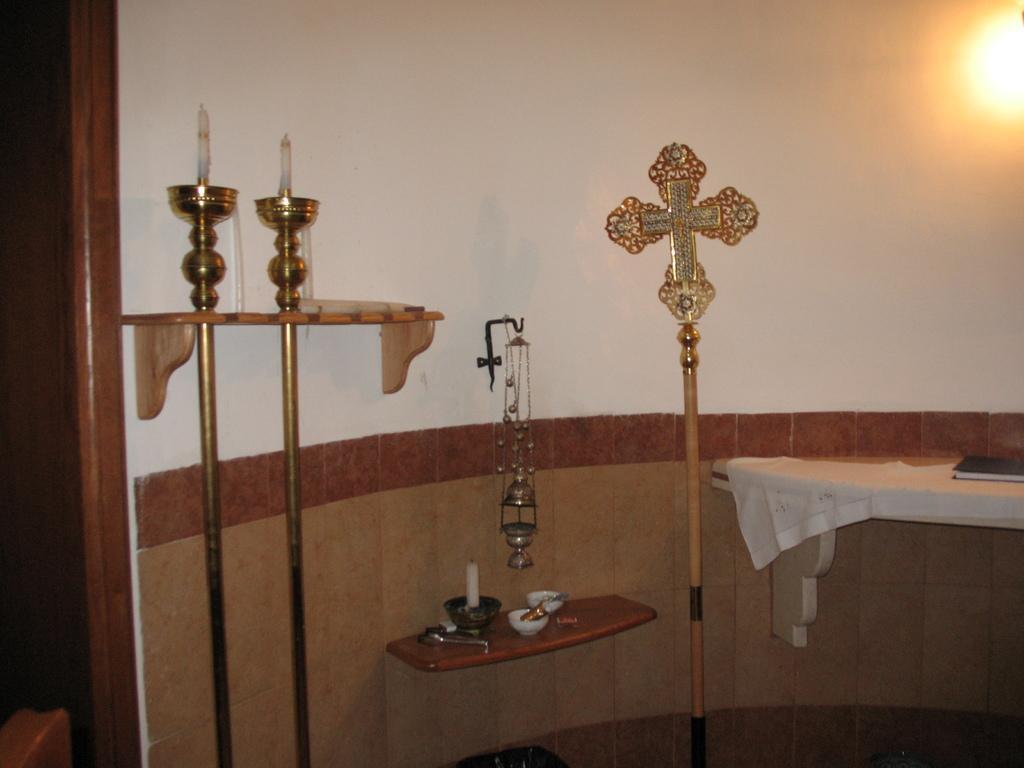In one or two sentences, can you explain what this image depicts? On the right side of the image there is a wooden board with white cloth and a book on it. Beside that there is a pole with cross mark. There is a wooden board with bowls, candles and few other items on it. On the wall there is a hook with something is hanging onto it. There are poles with candles. On the left side of the image there is a room. In the top right corner of the image there is a light. 